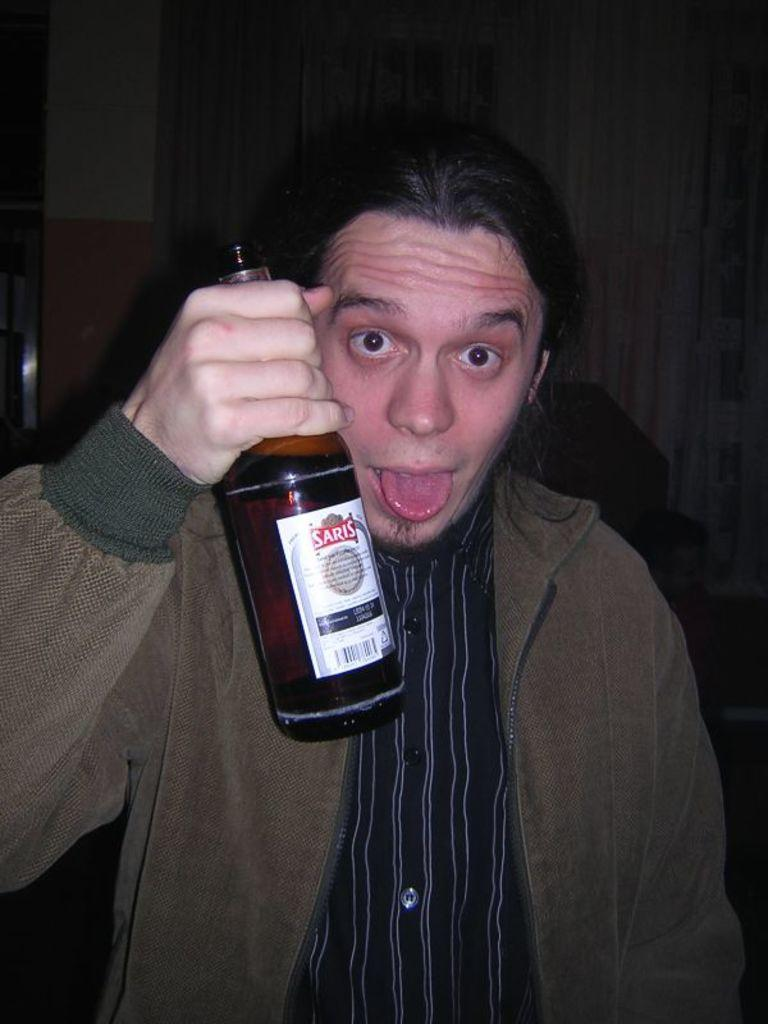What is the main subject of the image? There is a man in the image. What is the man doing in the image? The man is standing in the image. What object is the man holding in his hand? The man is holding a bottle in his hand. How many spiders are crawling on the man's shoulder in the image? There are no spiders present in the image. Is there a girl in the image? The image only features a man, so there is no girl present. 